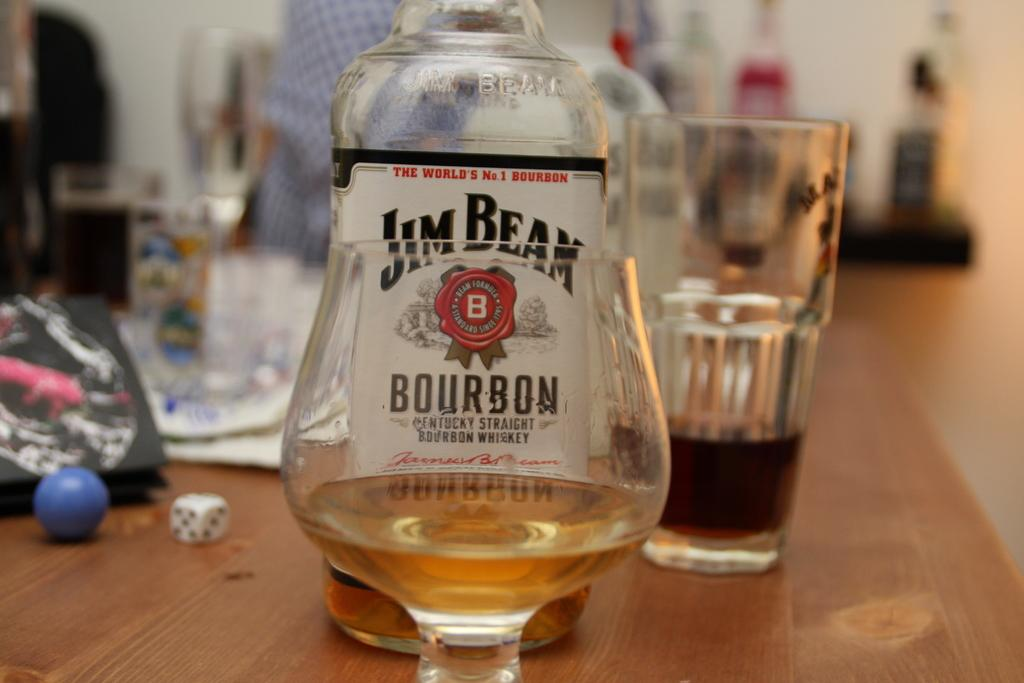<image>
Provide a brief description of the given image. a bottle of Jim Beam Bourbon standing behind a glass 